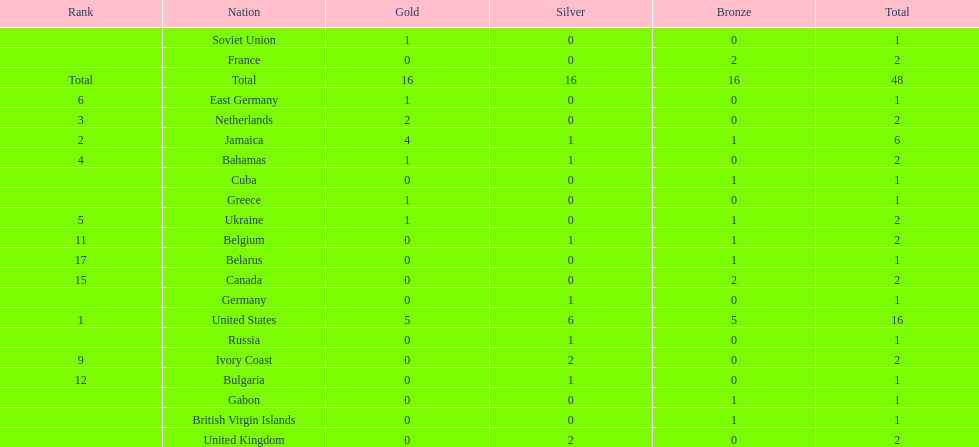What is the average number of gold medals won by the top 5 nations? 2.6. 